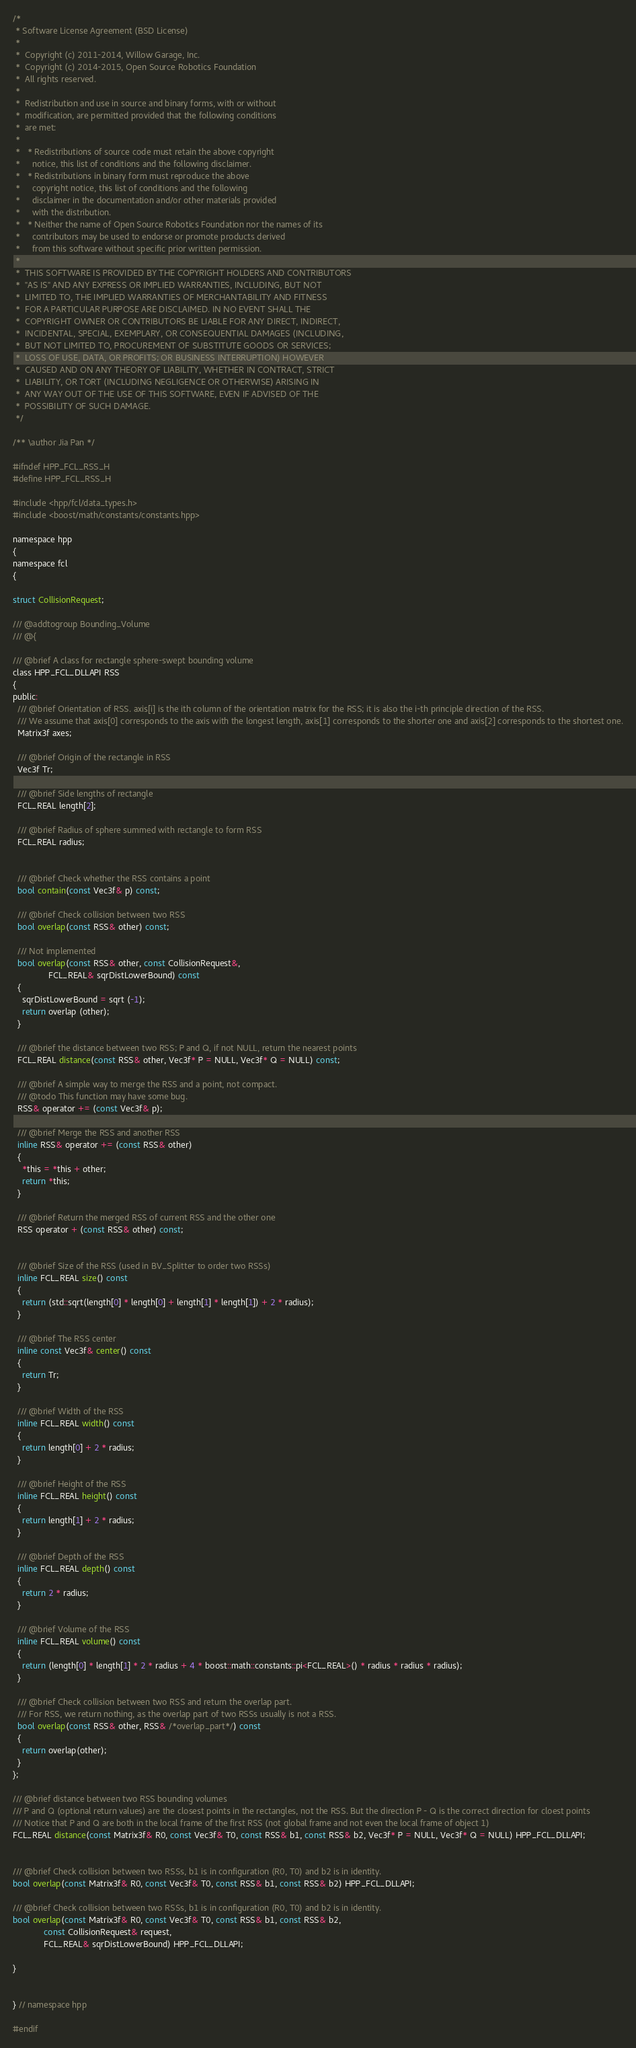Convert code to text. <code><loc_0><loc_0><loc_500><loc_500><_C_>/*
 * Software License Agreement (BSD License)
 *
 *  Copyright (c) 2011-2014, Willow Garage, Inc.
 *  Copyright (c) 2014-2015, Open Source Robotics Foundation
 *  All rights reserved.
 *
 *  Redistribution and use in source and binary forms, with or without
 *  modification, are permitted provided that the following conditions
 *  are met:
 *
 *   * Redistributions of source code must retain the above copyright
 *     notice, this list of conditions and the following disclaimer.
 *   * Redistributions in binary form must reproduce the above
 *     copyright notice, this list of conditions and the following
 *     disclaimer in the documentation and/or other materials provided
 *     with the distribution.
 *   * Neither the name of Open Source Robotics Foundation nor the names of its
 *     contributors may be used to endorse or promote products derived
 *     from this software without specific prior written permission.
 *
 *  THIS SOFTWARE IS PROVIDED BY THE COPYRIGHT HOLDERS AND CONTRIBUTORS
 *  "AS IS" AND ANY EXPRESS OR IMPLIED WARRANTIES, INCLUDING, BUT NOT
 *  LIMITED TO, THE IMPLIED WARRANTIES OF MERCHANTABILITY AND FITNESS
 *  FOR A PARTICULAR PURPOSE ARE DISCLAIMED. IN NO EVENT SHALL THE
 *  COPYRIGHT OWNER OR CONTRIBUTORS BE LIABLE FOR ANY DIRECT, INDIRECT,
 *  INCIDENTAL, SPECIAL, EXEMPLARY, OR CONSEQUENTIAL DAMAGES (INCLUDING,
 *  BUT NOT LIMITED TO, PROCUREMENT OF SUBSTITUTE GOODS OR SERVICES;
 *  LOSS OF USE, DATA, OR PROFITS; OR BUSINESS INTERRUPTION) HOWEVER
 *  CAUSED AND ON ANY THEORY OF LIABILITY, WHETHER IN CONTRACT, STRICT
 *  LIABILITY, OR TORT (INCLUDING NEGLIGENCE OR OTHERWISE) ARISING IN
 *  ANY WAY OUT OF THE USE OF THIS SOFTWARE, EVEN IF ADVISED OF THE
 *  POSSIBILITY OF SUCH DAMAGE.
 */

/** \author Jia Pan */

#ifndef HPP_FCL_RSS_H
#define HPP_FCL_RSS_H

#include <hpp/fcl/data_types.h>
#include <boost/math/constants/constants.hpp>

namespace hpp
{
namespace fcl
{

struct CollisionRequest;

/// @addtogroup Bounding_Volume
/// @{

/// @brief A class for rectangle sphere-swept bounding volume
class HPP_FCL_DLLAPI RSS
{
public:
  /// @brief Orientation of RSS. axis[i] is the ith column of the orientation matrix for the RSS; it is also the i-th principle direction of the RSS.
  /// We assume that axis[0] corresponds to the axis with the longest length, axis[1] corresponds to the shorter one and axis[2] corresponds to the shortest one.
  Matrix3f axes;

  /// @brief Origin of the rectangle in RSS
  Vec3f Tr;

  /// @brief Side lengths of rectangle
  FCL_REAL length[2];

  /// @brief Radius of sphere summed with rectangle to form RSS
  FCL_REAL radius;


  /// @brief Check whether the RSS contains a point
  bool contain(const Vec3f& p) const;

  /// @brief Check collision between two RSS
  bool overlap(const RSS& other) const;

  /// Not implemented
  bool overlap(const RSS& other, const CollisionRequest&,
               FCL_REAL& sqrDistLowerBound) const
  {
    sqrDistLowerBound = sqrt (-1);
    return overlap (other);
  }

  /// @brief the distance between two RSS; P and Q, if not NULL, return the nearest points
  FCL_REAL distance(const RSS& other, Vec3f* P = NULL, Vec3f* Q = NULL) const;

  /// @brief A simple way to merge the RSS and a point, not compact.
  /// @todo This function may have some bug.
  RSS& operator += (const Vec3f& p);

  /// @brief Merge the RSS and another RSS
  inline RSS& operator += (const RSS& other)
  {
    *this = *this + other;
    return *this;
  }

  /// @brief Return the merged RSS of current RSS and the other one
  RSS operator + (const RSS& other) const;


  /// @brief Size of the RSS (used in BV_Splitter to order two RSSs)
  inline FCL_REAL size() const
  {
    return (std::sqrt(length[0] * length[0] + length[1] * length[1]) + 2 * radius);
  }

  /// @brief The RSS center
  inline const Vec3f& center() const
  {
    return Tr;
  }

  /// @brief Width of the RSS
  inline FCL_REAL width() const
  {
    return length[0] + 2 * radius;
  }

  /// @brief Height of the RSS
  inline FCL_REAL height() const
  {
    return length[1] + 2 * radius;
  }

  /// @brief Depth of the RSS
  inline FCL_REAL depth() const
  {
    return 2 * radius;
  }

  /// @brief Volume of the RSS
  inline FCL_REAL volume() const
  {
    return (length[0] * length[1] * 2 * radius + 4 * boost::math::constants::pi<FCL_REAL>() * radius * radius * radius);
  }

  /// @brief Check collision between two RSS and return the overlap part.
  /// For RSS, we return nothing, as the overlap part of two RSSs usually is not a RSS.
  bool overlap(const RSS& other, RSS& /*overlap_part*/) const
  {
    return overlap(other);
  }
};

/// @brief distance between two RSS bounding volumes
/// P and Q (optional return values) are the closest points in the rectangles, not the RSS. But the direction P - Q is the correct direction for cloest points
/// Notice that P and Q are both in the local frame of the first RSS (not global frame and not even the local frame of object 1)
FCL_REAL distance(const Matrix3f& R0, const Vec3f& T0, const RSS& b1, const RSS& b2, Vec3f* P = NULL, Vec3f* Q = NULL) HPP_FCL_DLLAPI;


/// @brief Check collision between two RSSs, b1 is in configuration (R0, T0) and b2 is in identity.
bool overlap(const Matrix3f& R0, const Vec3f& T0, const RSS& b1, const RSS& b2) HPP_FCL_DLLAPI;

/// @brief Check collision between two RSSs, b1 is in configuration (R0, T0) and b2 is in identity.
bool overlap(const Matrix3f& R0, const Vec3f& T0, const RSS& b1, const RSS& b2,
             const CollisionRequest& request,
             FCL_REAL& sqrDistLowerBound) HPP_FCL_DLLAPI;

}


} // namespace hpp

#endif
</code> 